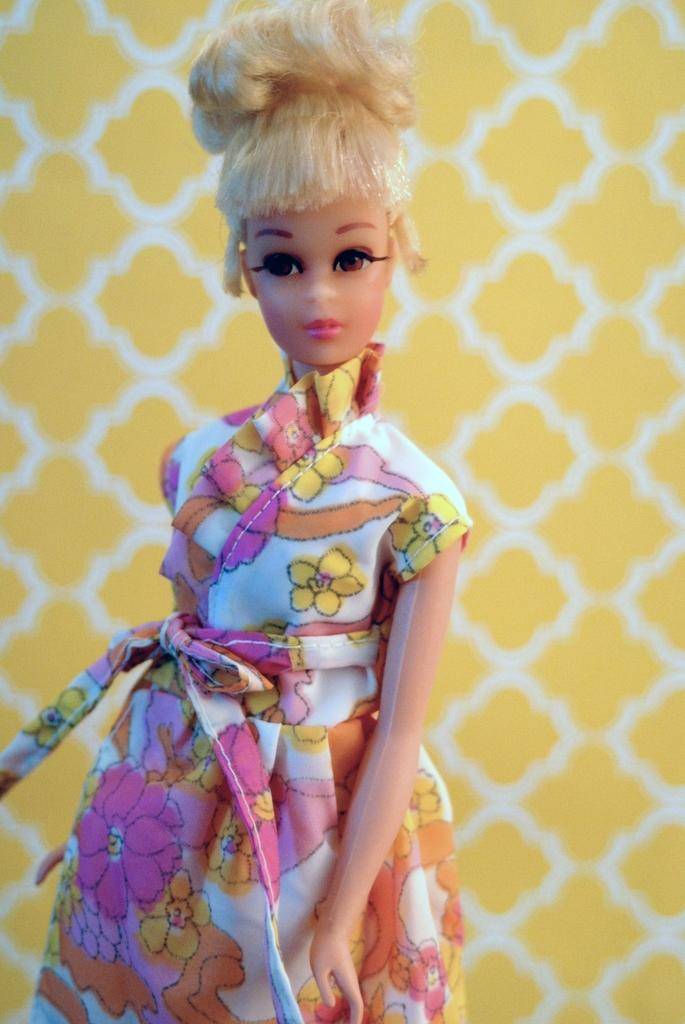What is the main subject in the center of the image? There is a doll in the center of the image. What can be seen in the background of the image? There is a wall in the background of the image. Where is the nest located in the image? There is no nest present in the image. What type of answer can be seen written on the wall in the image? There is no answer written on the wall in the image. 